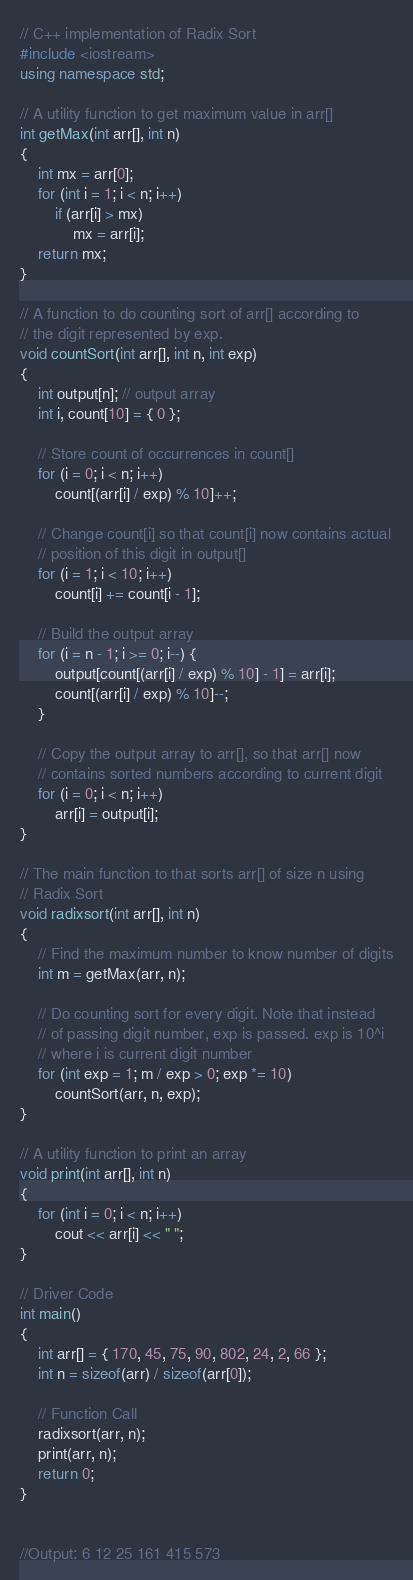Convert code to text. <code><loc_0><loc_0><loc_500><loc_500><_C++_>// C++ implementation of Radix Sort
#include <iostream>
using namespace std;

// A utility function to get maximum value in arr[]
int getMax(int arr[], int n)
{
	int mx = arr[0];
	for (int i = 1; i < n; i++)
		if (arr[i] > mx)
			mx = arr[i];
	return mx;
}

// A function to do counting sort of arr[] according to
// the digit represented by exp.
void countSort(int arr[], int n, int exp)
{
	int output[n]; // output array
	int i, count[10] = { 0 };

	// Store count of occurrences in count[]
	for (i = 0; i < n; i++)
		count[(arr[i] / exp) % 10]++;

	// Change count[i] so that count[i] now contains actual
	// position of this digit in output[]
	for (i = 1; i < 10; i++)
		count[i] += count[i - 1];

	// Build the output array
	for (i = n - 1; i >= 0; i--) {
		output[count[(arr[i] / exp) % 10] - 1] = arr[i];
		count[(arr[i] / exp) % 10]--;
	}

	// Copy the output array to arr[], so that arr[] now
	// contains sorted numbers according to current digit
	for (i = 0; i < n; i++)
		arr[i] = output[i];
}

// The main function to that sorts arr[] of size n using
// Radix Sort
void radixsort(int arr[], int n)
{
	// Find the maximum number to know number of digits
	int m = getMax(arr, n);

	// Do counting sort for every digit. Note that instead
	// of passing digit number, exp is passed. exp is 10^i
	// where i is current digit number
	for (int exp = 1; m / exp > 0; exp *= 10)
		countSort(arr, n, exp);
}

// A utility function to print an array
void print(int arr[], int n)
{
	for (int i = 0; i < n; i++)
		cout << arr[i] << " ";
}

// Driver Code
int main()
{
	int arr[] = { 170, 45, 75, 90, 802, 24, 2, 66 };
	int n = sizeof(arr) / sizeof(arr[0]);
	
	// Function Call
	radixsort(arr, n);
	print(arr, n);
	return 0;
}


//Output: 6 12 25 161 415 573 
</code> 